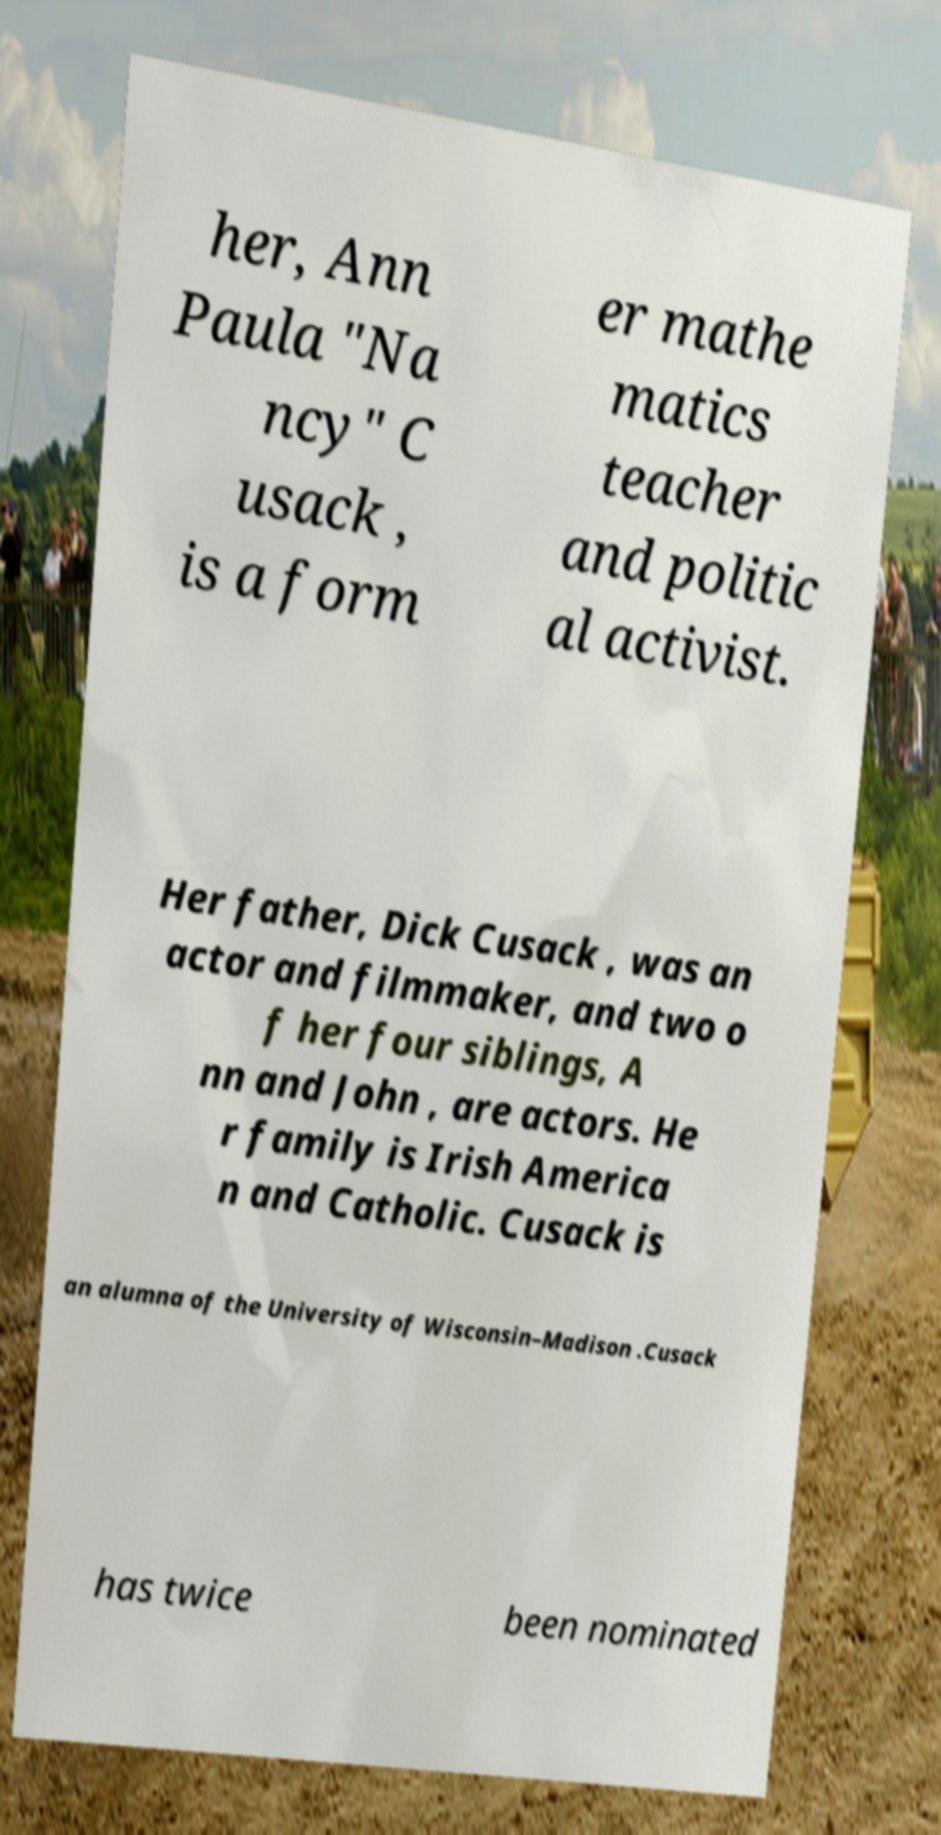What messages or text are displayed in this image? I need them in a readable, typed format. her, Ann Paula "Na ncy" C usack , is a form er mathe matics teacher and politic al activist. Her father, Dick Cusack , was an actor and filmmaker, and two o f her four siblings, A nn and John , are actors. He r family is Irish America n and Catholic. Cusack is an alumna of the University of Wisconsin–Madison .Cusack has twice been nominated 